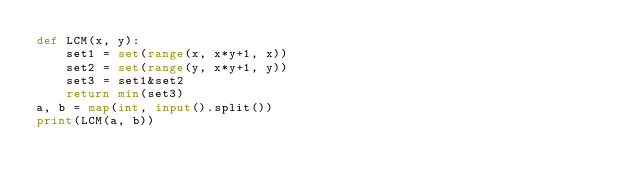Convert code to text. <code><loc_0><loc_0><loc_500><loc_500><_Python_>def LCM(x, y):
    set1 = set(range(x, x*y+1, x))
    set2 = set(range(y, x*y+1, y))
    set3 = set1&set2
    return min(set3)
a, b = map(int, input().split())
print(LCM(a, b))</code> 